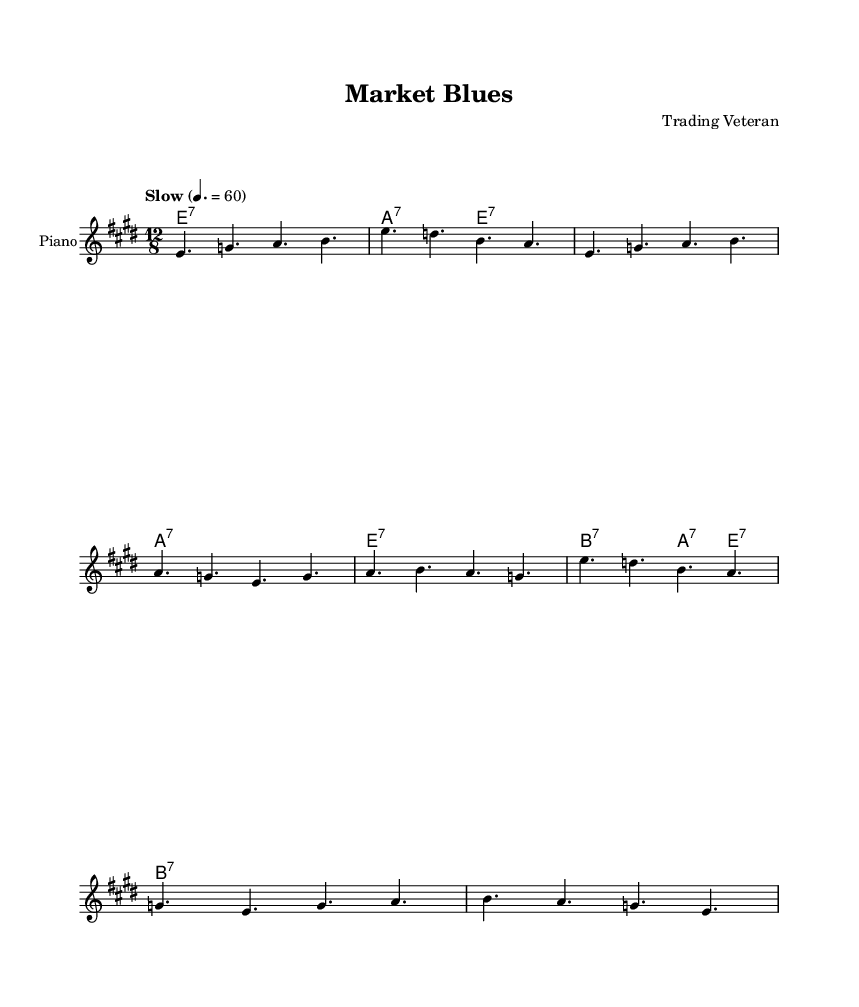What is the key signature of this music? The key signature is E major, as indicated by the presence of four sharps in the key signature area.
Answer: E major What is the time signature of this music? The time signature shown at the beginning is 12/8, which means there are twelve eighth notes in each measure.
Answer: 12/8 What is the tempo marking for this piece? The tempo marking indicated in the music is "Slow" with a specific tempo of quarter note equals 60 beats per minute.
Answer: Slow How many measures are in the verse section? The verse section consists of two measures of music based on the melody and lyrics provided before the chorus begins.
Answer: 2 What is the form of this piece? The structure consists of a verse followed by a chorus, which is typical in blues music, showcasing both lyrical and musical themes.
Answer: Verse-Chorus What emotional tone is conveyed in the lyrics? The lyrics express feelings of loss and lament, indicating sadness over financial setbacks and the struggle following economic downturns, typical themes in blues music.
Answer: Lamentation How do the chords in the chorus contribute to the blues style? The chords support a typical blues progression, often using dominant seventh chords which create a sense of tension and resolution, characteristic of the blues genre.
Answer: Dominant seventh chords 